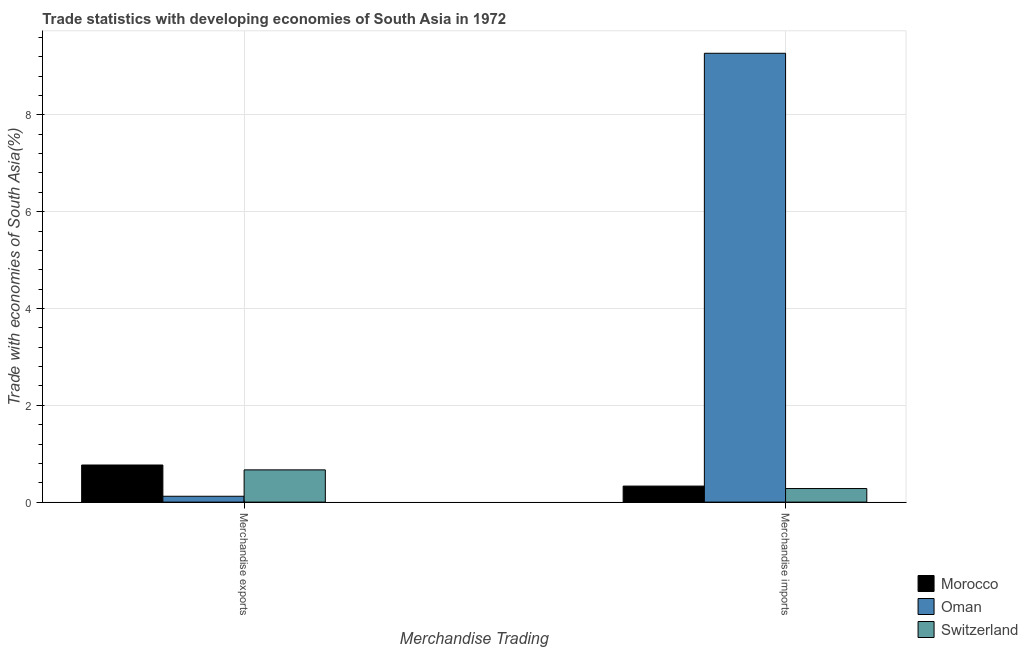How many groups of bars are there?
Keep it short and to the point. 2. Are the number of bars per tick equal to the number of legend labels?
Keep it short and to the point. Yes. How many bars are there on the 2nd tick from the right?
Ensure brevity in your answer.  3. What is the merchandise imports in Morocco?
Keep it short and to the point. 0.33. Across all countries, what is the maximum merchandise exports?
Offer a terse response. 0.77. Across all countries, what is the minimum merchandise exports?
Make the answer very short. 0.12. In which country was the merchandise exports maximum?
Your answer should be compact. Morocco. In which country was the merchandise exports minimum?
Your answer should be compact. Oman. What is the total merchandise exports in the graph?
Your answer should be compact. 1.55. What is the difference between the merchandise exports in Switzerland and that in Oman?
Your answer should be very brief. 0.55. What is the difference between the merchandise imports in Switzerland and the merchandise exports in Morocco?
Offer a very short reply. -0.49. What is the average merchandise imports per country?
Your answer should be compact. 3.29. What is the difference between the merchandise imports and merchandise exports in Morocco?
Make the answer very short. -0.44. What is the ratio of the merchandise imports in Morocco to that in Switzerland?
Your answer should be compact. 1.18. What does the 2nd bar from the left in Merchandise imports represents?
Your answer should be very brief. Oman. What does the 1st bar from the right in Merchandise exports represents?
Keep it short and to the point. Switzerland. How many bars are there?
Keep it short and to the point. 6. Are all the bars in the graph horizontal?
Your answer should be compact. No. Does the graph contain grids?
Offer a terse response. Yes. How many legend labels are there?
Provide a short and direct response. 3. What is the title of the graph?
Your answer should be very brief. Trade statistics with developing economies of South Asia in 1972. What is the label or title of the X-axis?
Provide a succinct answer. Merchandise Trading. What is the label or title of the Y-axis?
Your response must be concise. Trade with economies of South Asia(%). What is the Trade with economies of South Asia(%) in Morocco in Merchandise exports?
Give a very brief answer. 0.77. What is the Trade with economies of South Asia(%) in Oman in Merchandise exports?
Your answer should be compact. 0.12. What is the Trade with economies of South Asia(%) in Switzerland in Merchandise exports?
Your answer should be very brief. 0.67. What is the Trade with economies of South Asia(%) in Morocco in Merchandise imports?
Keep it short and to the point. 0.33. What is the Trade with economies of South Asia(%) in Oman in Merchandise imports?
Offer a terse response. 9.27. What is the Trade with economies of South Asia(%) of Switzerland in Merchandise imports?
Give a very brief answer. 0.28. Across all Merchandise Trading, what is the maximum Trade with economies of South Asia(%) of Morocco?
Your response must be concise. 0.77. Across all Merchandise Trading, what is the maximum Trade with economies of South Asia(%) of Oman?
Offer a very short reply. 9.27. Across all Merchandise Trading, what is the maximum Trade with economies of South Asia(%) in Switzerland?
Offer a very short reply. 0.67. Across all Merchandise Trading, what is the minimum Trade with economies of South Asia(%) in Morocco?
Your response must be concise. 0.33. Across all Merchandise Trading, what is the minimum Trade with economies of South Asia(%) of Oman?
Keep it short and to the point. 0.12. Across all Merchandise Trading, what is the minimum Trade with economies of South Asia(%) in Switzerland?
Give a very brief answer. 0.28. What is the total Trade with economies of South Asia(%) of Morocco in the graph?
Provide a succinct answer. 1.1. What is the total Trade with economies of South Asia(%) of Oman in the graph?
Provide a succinct answer. 9.39. What is the total Trade with economies of South Asia(%) in Switzerland in the graph?
Give a very brief answer. 0.95. What is the difference between the Trade with economies of South Asia(%) of Morocco in Merchandise exports and that in Merchandise imports?
Your answer should be very brief. 0.44. What is the difference between the Trade with economies of South Asia(%) of Oman in Merchandise exports and that in Merchandise imports?
Your answer should be very brief. -9.15. What is the difference between the Trade with economies of South Asia(%) in Switzerland in Merchandise exports and that in Merchandise imports?
Your response must be concise. 0.39. What is the difference between the Trade with economies of South Asia(%) in Morocco in Merchandise exports and the Trade with economies of South Asia(%) in Oman in Merchandise imports?
Ensure brevity in your answer.  -8.5. What is the difference between the Trade with economies of South Asia(%) of Morocco in Merchandise exports and the Trade with economies of South Asia(%) of Switzerland in Merchandise imports?
Provide a succinct answer. 0.49. What is the difference between the Trade with economies of South Asia(%) in Oman in Merchandise exports and the Trade with economies of South Asia(%) in Switzerland in Merchandise imports?
Offer a very short reply. -0.16. What is the average Trade with economies of South Asia(%) of Morocco per Merchandise Trading?
Your response must be concise. 0.55. What is the average Trade with economies of South Asia(%) in Oman per Merchandise Trading?
Offer a very short reply. 4.7. What is the average Trade with economies of South Asia(%) in Switzerland per Merchandise Trading?
Your answer should be compact. 0.47. What is the difference between the Trade with economies of South Asia(%) of Morocco and Trade with economies of South Asia(%) of Oman in Merchandise exports?
Your answer should be compact. 0.65. What is the difference between the Trade with economies of South Asia(%) in Morocco and Trade with economies of South Asia(%) in Switzerland in Merchandise exports?
Ensure brevity in your answer.  0.1. What is the difference between the Trade with economies of South Asia(%) of Oman and Trade with economies of South Asia(%) of Switzerland in Merchandise exports?
Provide a short and direct response. -0.55. What is the difference between the Trade with economies of South Asia(%) of Morocco and Trade with economies of South Asia(%) of Oman in Merchandise imports?
Make the answer very short. -8.94. What is the difference between the Trade with economies of South Asia(%) in Morocco and Trade with economies of South Asia(%) in Switzerland in Merchandise imports?
Your response must be concise. 0.05. What is the difference between the Trade with economies of South Asia(%) in Oman and Trade with economies of South Asia(%) in Switzerland in Merchandise imports?
Offer a very short reply. 8.99. What is the ratio of the Trade with economies of South Asia(%) of Morocco in Merchandise exports to that in Merchandise imports?
Your response must be concise. 2.32. What is the ratio of the Trade with economies of South Asia(%) of Oman in Merchandise exports to that in Merchandise imports?
Your answer should be very brief. 0.01. What is the ratio of the Trade with economies of South Asia(%) of Switzerland in Merchandise exports to that in Merchandise imports?
Keep it short and to the point. 2.37. What is the difference between the highest and the second highest Trade with economies of South Asia(%) in Morocco?
Offer a terse response. 0.44. What is the difference between the highest and the second highest Trade with economies of South Asia(%) of Oman?
Provide a short and direct response. 9.15. What is the difference between the highest and the second highest Trade with economies of South Asia(%) of Switzerland?
Offer a terse response. 0.39. What is the difference between the highest and the lowest Trade with economies of South Asia(%) in Morocco?
Provide a short and direct response. 0.44. What is the difference between the highest and the lowest Trade with economies of South Asia(%) in Oman?
Make the answer very short. 9.15. What is the difference between the highest and the lowest Trade with economies of South Asia(%) in Switzerland?
Your response must be concise. 0.39. 